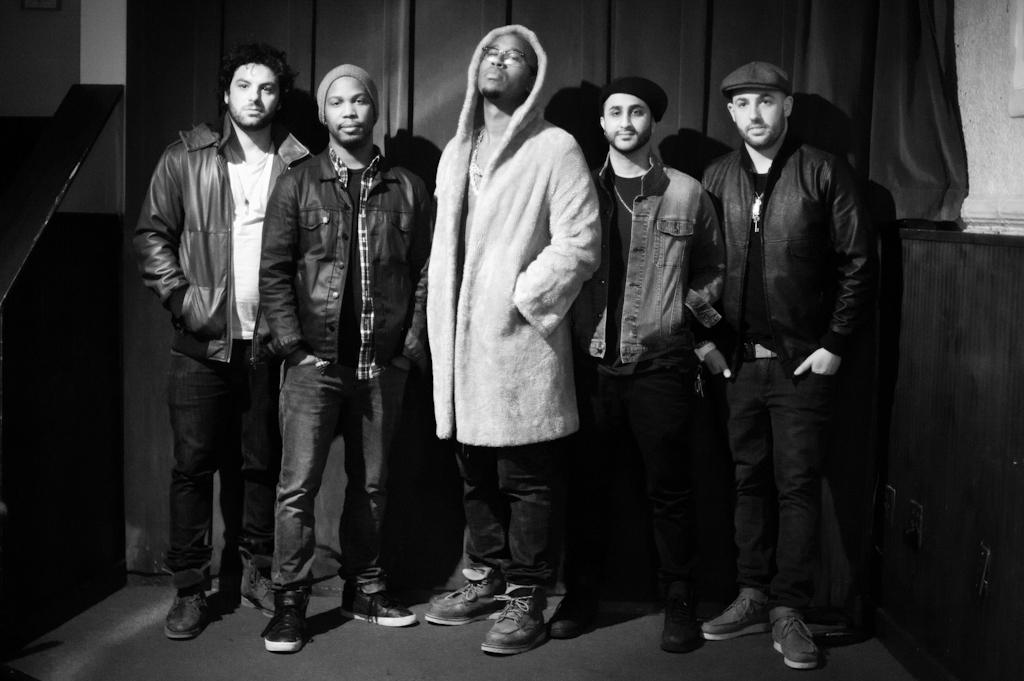How many people are in the image? There is a group of people in the image. What is the position of the people in the image? The people are standing on the ground. What can be seen in the background of the image? There is an object, a wall, and a curtain in the background of the image. What color are the eyes of the unit in the image? There is no unit present in the image, and therefore no eyes to describe. 